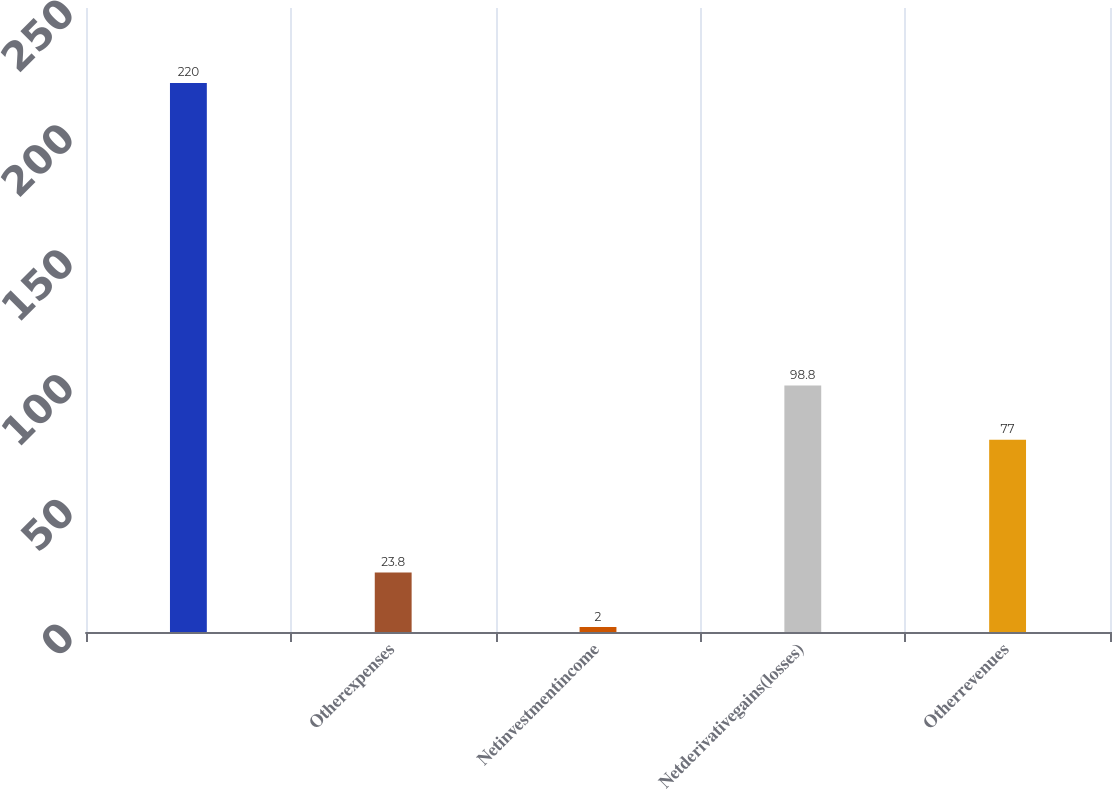Convert chart. <chart><loc_0><loc_0><loc_500><loc_500><bar_chart><ecel><fcel>Otherexpenses<fcel>Netinvestmentincome<fcel>Netderivativegains(losses)<fcel>Otherrevenues<nl><fcel>220<fcel>23.8<fcel>2<fcel>98.8<fcel>77<nl></chart> 